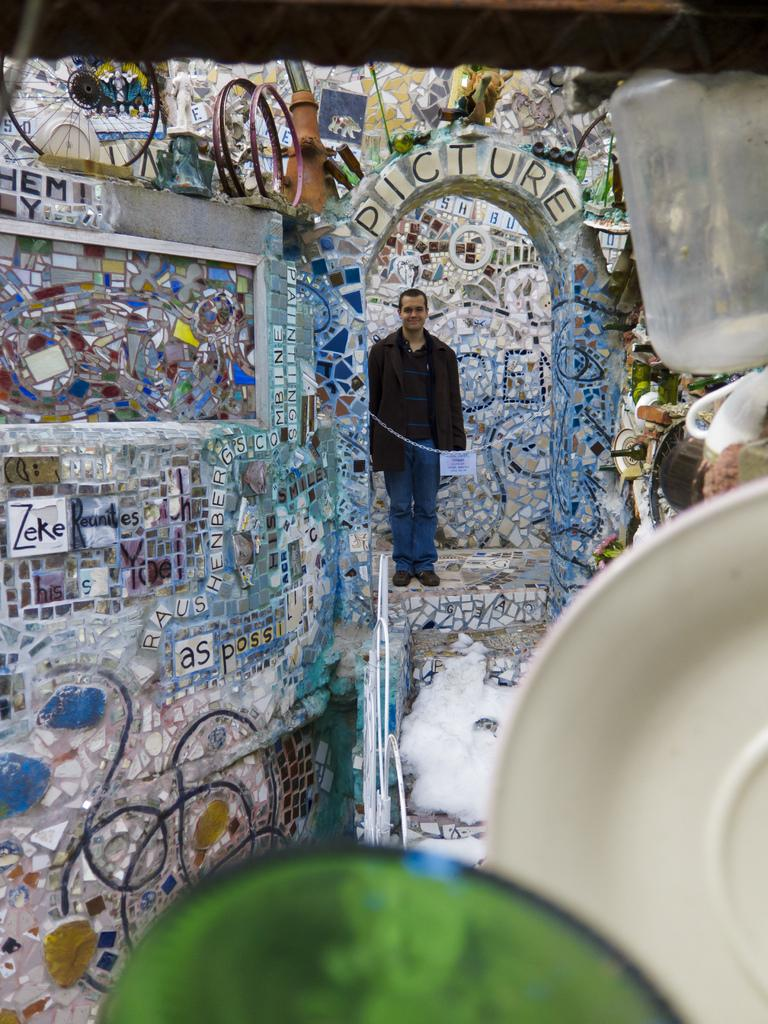What is the primary subject in the image? There is a person standing in the image. What is the person's position in relation to the ground? The person is standing on the ground. What else can be seen in the image besides the person? There are objects visible in the image. What type of pear is the person holding in the image? There is no pear present in the image; the person is not holding anything. 